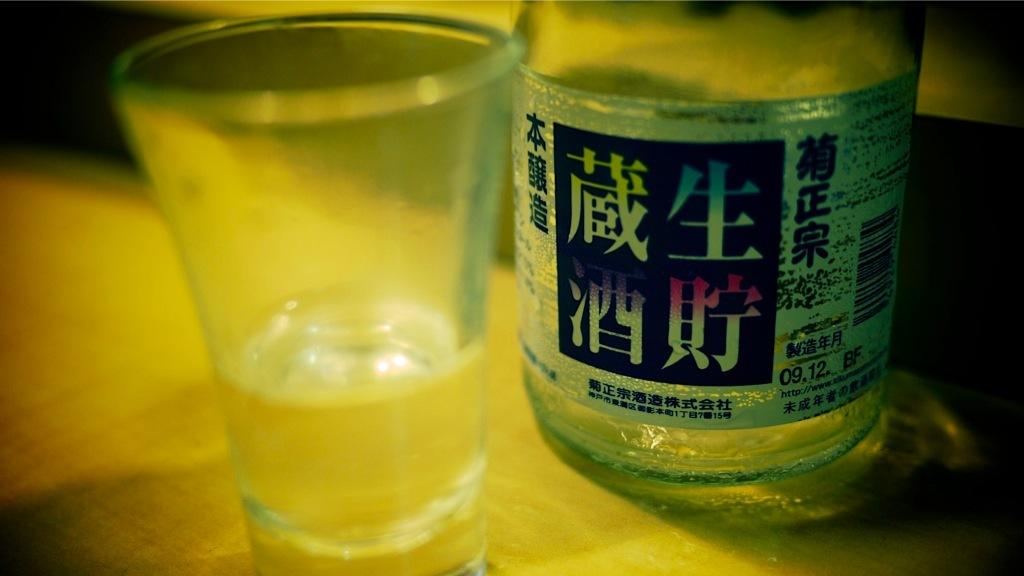<image>
Give a short and clear explanation of the subsequent image. A bottle of alcohol has the number 09.12 on the side of the label. 